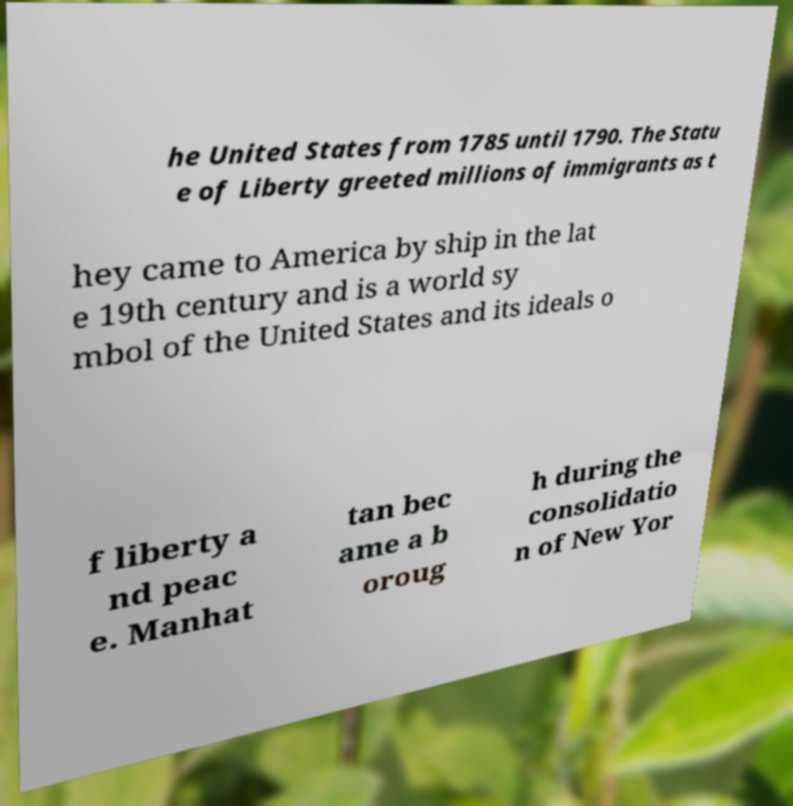Please read and relay the text visible in this image. What does it say? he United States from 1785 until 1790. The Statu e of Liberty greeted millions of immigrants as t hey came to America by ship in the lat e 19th century and is a world sy mbol of the United States and its ideals o f liberty a nd peac e. Manhat tan bec ame a b oroug h during the consolidatio n of New Yor 